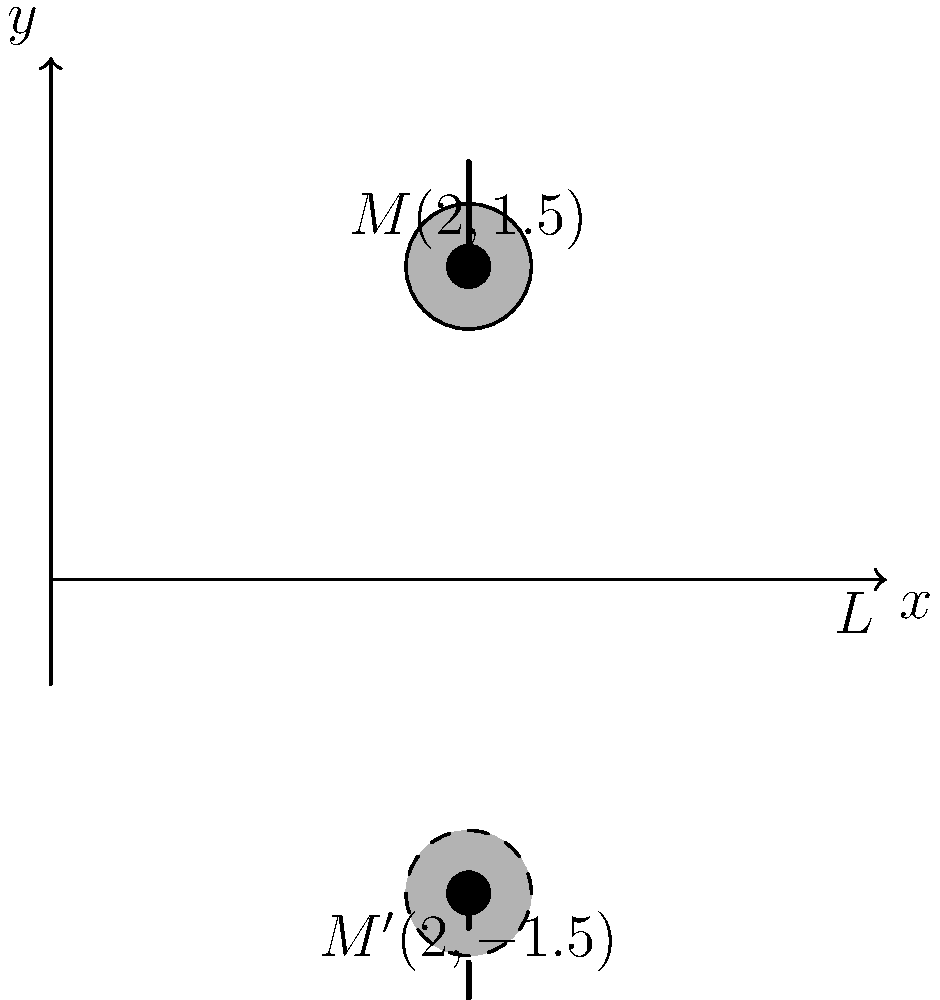As part of designing a symmetrical logo for your Afrobeat music brand, you want to reflect a microphone icon across a horizontal line. The original microphone icon is centered at point $M(2,1.5)$. If you reflect this icon across the x-axis (line $L$), what will be the coordinates of the center of the reflected microphone icon $M'$? To find the coordinates of the reflected point $M'$, we need to apply the reflection transformation across the x-axis. Here's how we do it:

1) The general rule for reflecting a point $(x,y)$ across the x-axis is to keep the x-coordinate the same and negate the y-coordinate.

2) Our original point $M$ has coordinates $(2,1.5)$.

3) After reflection:
   - The x-coordinate remains the same: 2
   - The y-coordinate is negated: $1.5$ becomes $-1.5$

4) Therefore, the coordinates of the reflected point $M'$ are $(2,-1.5)$.

This reflection creates a symmetrical design across the x-axis, which could be an effective element in your logo design, representing the duality or balance in your music.
Answer: $(2,-1.5)$ 